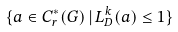<formula> <loc_0><loc_0><loc_500><loc_500>\{ a \in C ^ { \ast } _ { r } ( G ) \, | \, L _ { D } ^ { k } ( a ) \leq 1 \}</formula> 